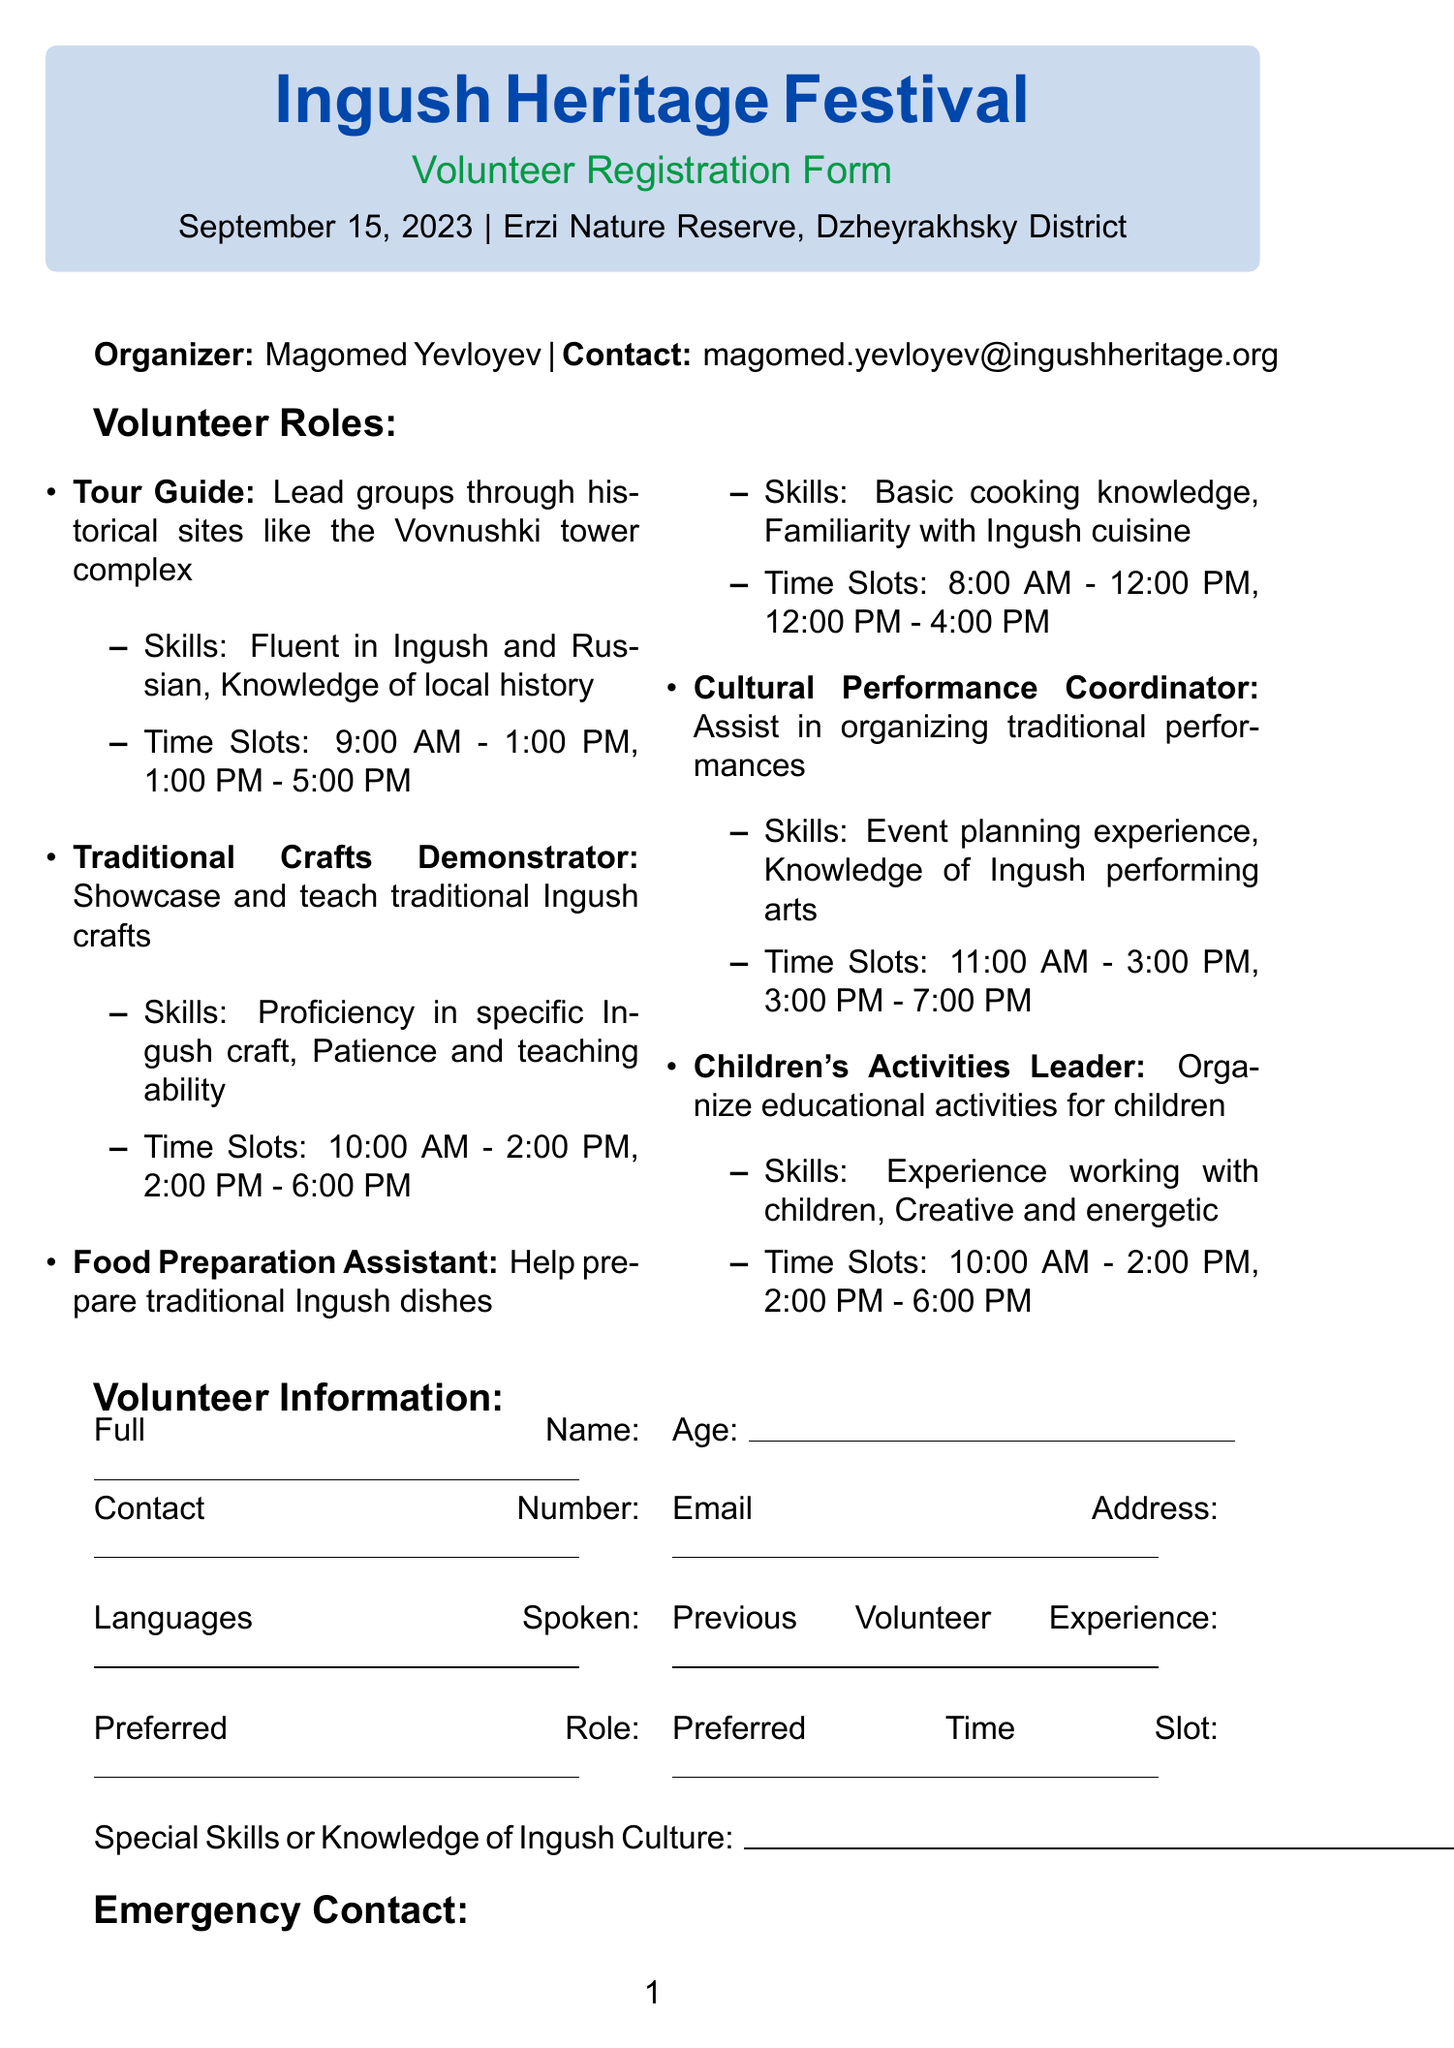What is the name of the event? The name of the event is mentioned at the top of the document.
Answer: Ingush Heritage Festival Who is the organizer of the event? The organizer's name is stated in the organizer section of the document.
Answer: Magomed Yevloyev What is the date of the event? The date can be found prominently in the document under the event details.
Answer: September 15, 2023 What role requires proficiency in a specific Ingush craft? This role is described in the volunteer roles section of the document.
Answer: Traditional Crafts Demonstrator What time slot does the Food Preparation Assistant work in the afternoon? The time slots for this role are detailed in the volunteer roles section.
Answer: 12:00 PM - 4:00 PM What is one of the benefits of volunteering? The benefits for volunteers are listed in a specific section of the document.
Answer: Free admission to all festival activities Do volunteers need previous experience for all roles? The document lists skills required for each role, indicating whether experience is necessary.
Answer: No What is the primary focus of the Children's Activities Leader role? This role's description helps determine its focus within the volunteer roles.
Answer: Organize educational activities about Ingush culture for children 